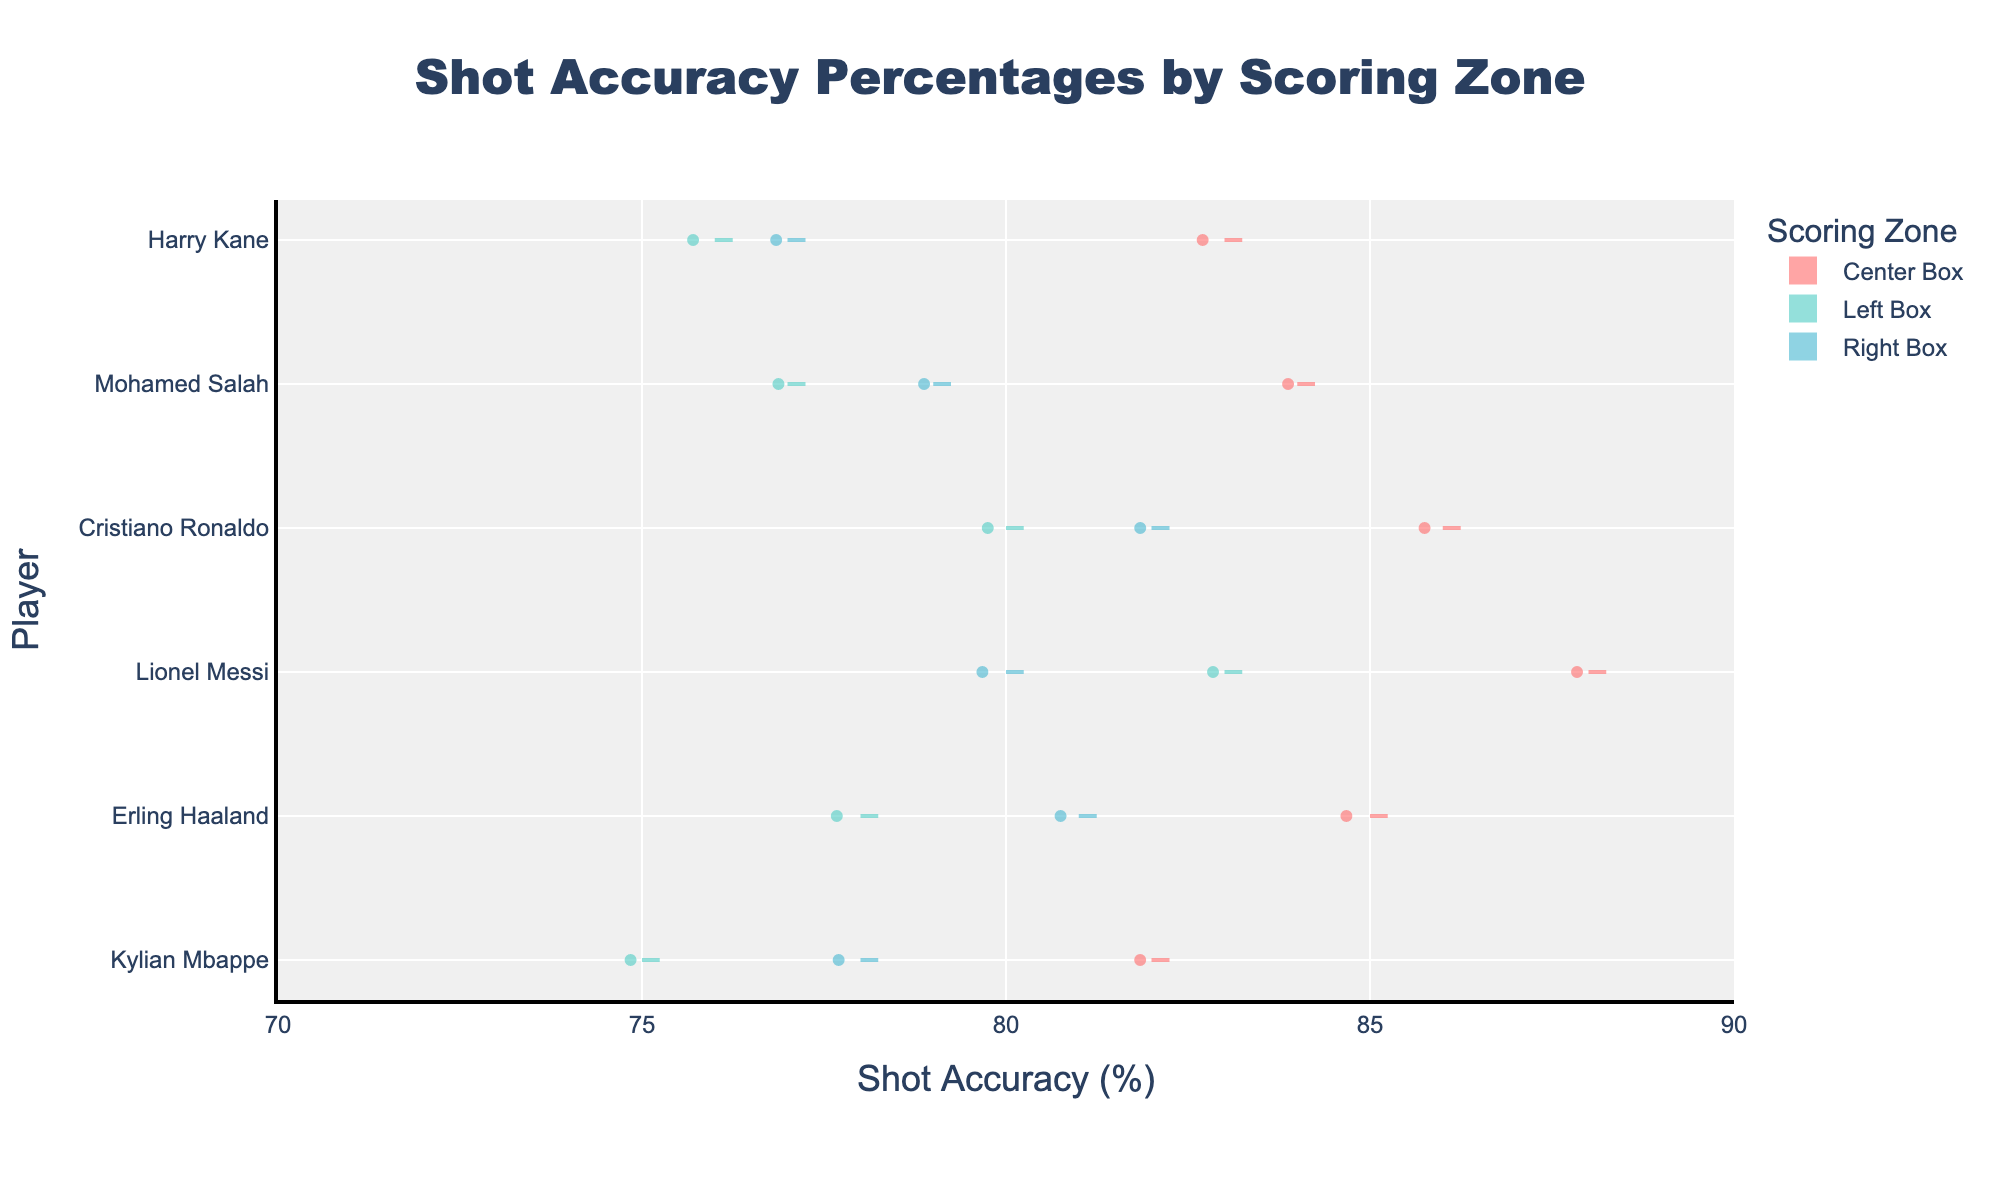What is the title of the chart? The title of the chart is located at the top center, and it summarizes the main subject of the figure in large, bold text.
Answer: Shot Accuracy Percentages by Scoring Zone Which scoring zone has the highest shot accuracy for Kylian Mbappe? By examining the points distribution for Kylian Mbappe across different scoring zones, we can observe which zone has the highest value.
Answer: Center Box How does Lionel Messi's shot accuracy in the Left Box compare to the Right Box? Compare the median and range of the distributions (represented by the violin plots) for Lionel Messi in both the Left and Right Box areas.
Answer: Higher in the Left Box What's the average shot accuracy in the Center Box for all players? To find the average, sum the shot accuracies of all players in the Center Box and divide it by the number of players: (82 + 85 + 88 + 86 + 84 + 83) ÷ 6.
Answer: 84.67 Which player has the widest spread of shot accuracy in different scoring zones? Check the overall variation in shot accuracy for each player across all scoring zones by comparing the widths of the violin plots.
Answer: Harry Kane Is the shot accuracy generally higher in the Center Box for most players? Observe the central tendency and spread of the violin plots for the Center Box and compare it with other scoring zones for each player.
Answer: Yes Does Erling Haaland have a higher shot accuracy in the Right Box or Left Box? Compare the median values indicated by the mean lines in the violin plots for the Right Box and Left Box for Erling Haaland.
Answer: Right Box Which player has the least variation in shot accuracy across different scoring zones? Identify the player with the most consistent median values and narrowest range across all violin plots for the different scoring zones.
Answer: Cristiano Ronaldo How does Mohamed Salah's shot accuracy in the Center Box compare to Harry Kane's? Compare the median values represented by the central horizontal line in the violin plots for Mohamed Salah and Harry Kane in the Center Box.
Answer: Higher Which scoring zone shows the biggest variance in shot accuracy among all players? Look for the scoring zone where the violin plots for all players have the widest spread or highest variability in their distributions.
Answer: Right Box 